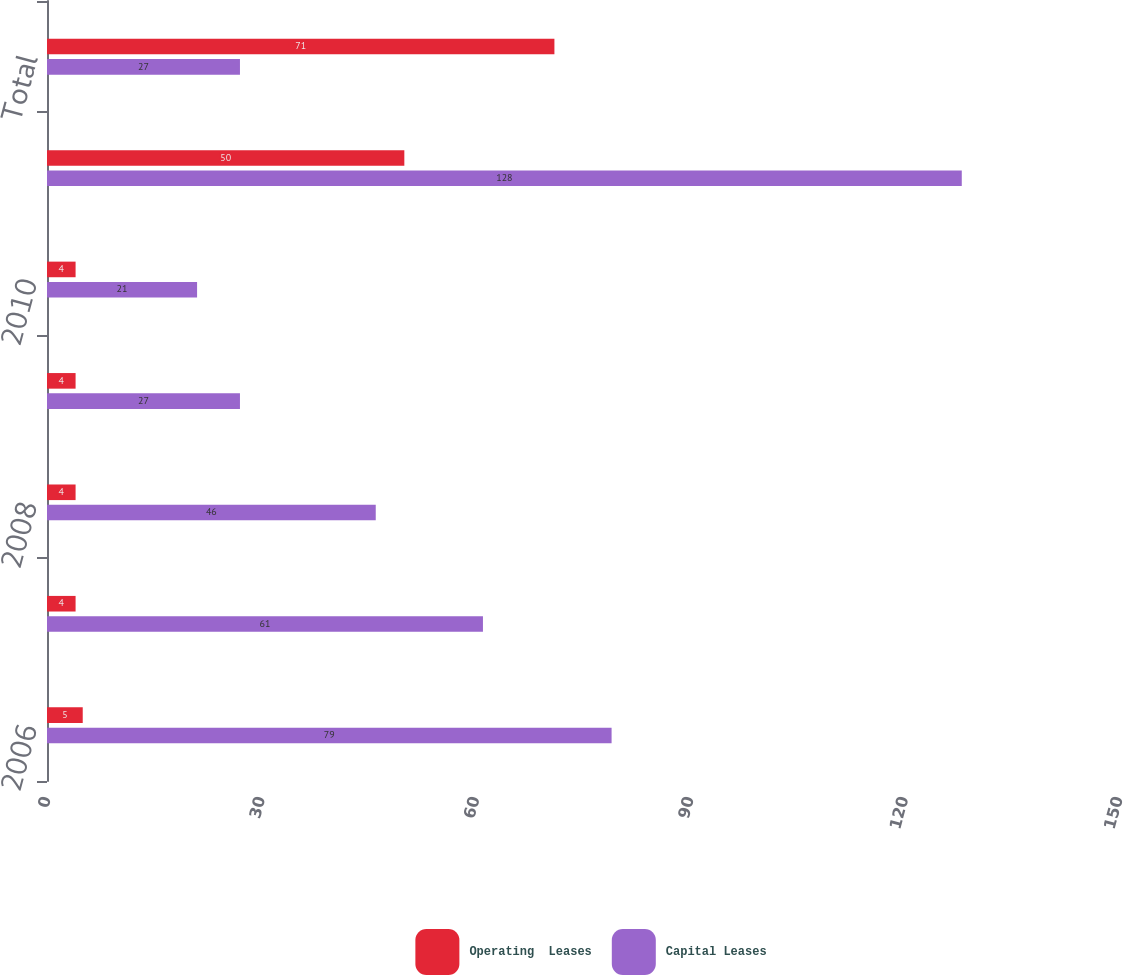Convert chart to OTSL. <chart><loc_0><loc_0><loc_500><loc_500><stacked_bar_chart><ecel><fcel>2006<fcel>2007<fcel>2008<fcel>2009<fcel>2010<fcel>After 2010<fcel>Total<nl><fcel>Operating  Leases<fcel>5<fcel>4<fcel>4<fcel>4<fcel>4<fcel>50<fcel>71<nl><fcel>Capital Leases<fcel>79<fcel>61<fcel>46<fcel>27<fcel>21<fcel>128<fcel>27<nl></chart> 